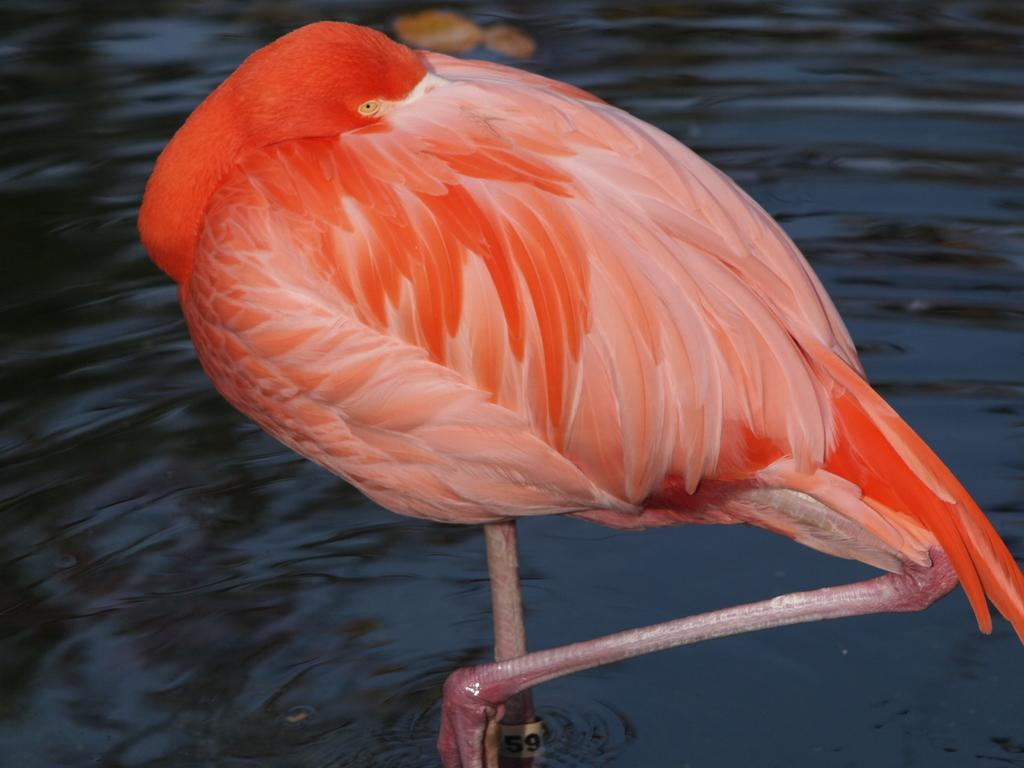What type of animal can be seen in the image? There is a bird in the image. What can be seen in the background of the image? There is water visible in the background of the image. What type of advice does the bird's uncle give in the image? There is no uncle present in the image, and therefore no advice can be given. 